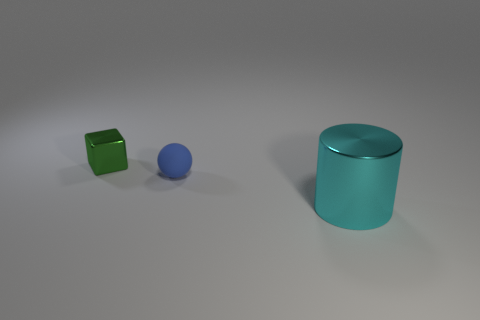Add 3 small green metallic objects. How many objects exist? 6 Subtract all cubes. How many objects are left? 2 Subtract 1 blue spheres. How many objects are left? 2 Subtract all big yellow matte cylinders. Subtract all tiny blue rubber things. How many objects are left? 2 Add 3 big cylinders. How many big cylinders are left? 4 Add 1 blue balls. How many blue balls exist? 2 